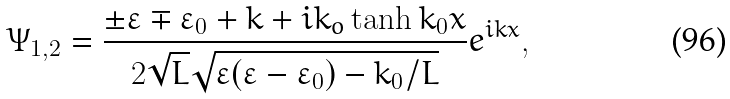Convert formula to latex. <formula><loc_0><loc_0><loc_500><loc_500>\Psi _ { 1 , 2 } = \frac { \pm \varepsilon \mp \varepsilon _ { 0 } + k + i k _ { o } \tanh k _ { 0 } x } { 2 \sqrt { L } \sqrt { \varepsilon ( \varepsilon - \varepsilon _ { 0 } ) - k _ { 0 } / L } } e ^ { i k x } ,</formula> 